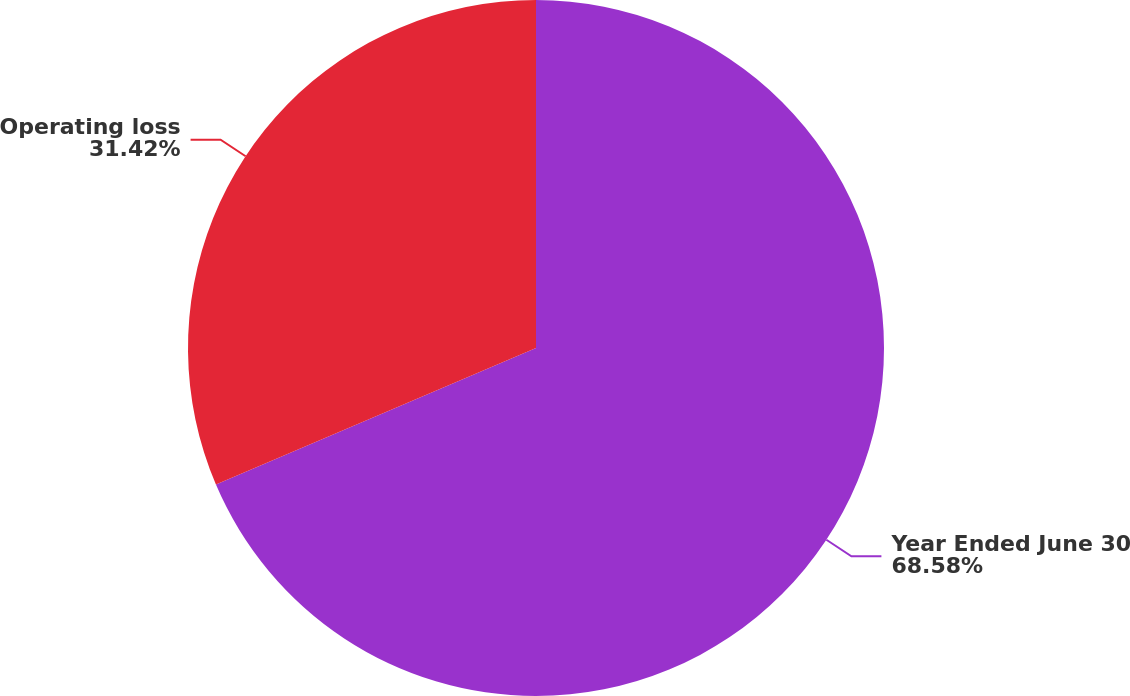Convert chart to OTSL. <chart><loc_0><loc_0><loc_500><loc_500><pie_chart><fcel>Year Ended June 30<fcel>Operating loss<nl><fcel>68.58%<fcel>31.42%<nl></chart> 